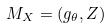<formula> <loc_0><loc_0><loc_500><loc_500>M _ { X } = ( g _ { \theta } , Z )</formula> 